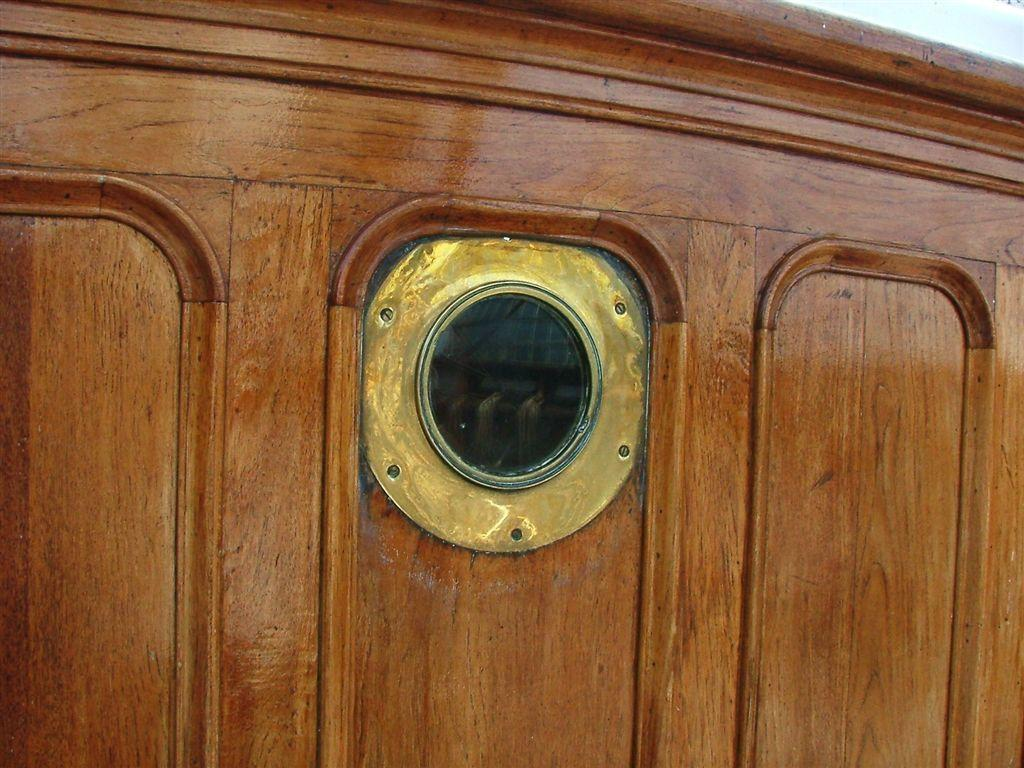What type of window is featured in the image? There is a brass striped glass window in the image. What material is the door made of that the window is on? The window is on a wooden door. What color is the sail on the hair in the image? There is no sail or hair present in the image; it only features a brass striped glass window on a wooden door. 